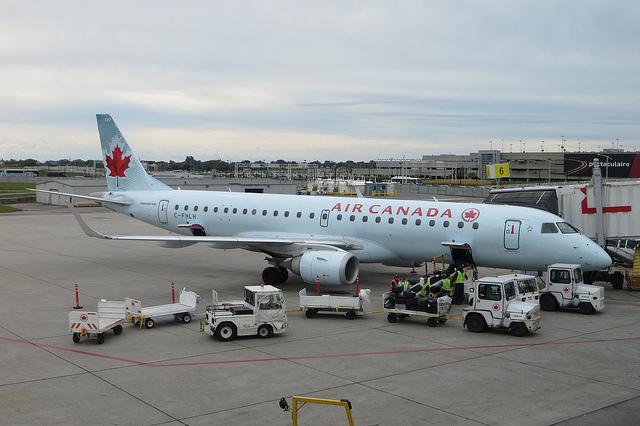Is the plane's door open?
Give a very brief answer. No. Is the plane taking off?
Give a very brief answer. No. Is the plane being loaded with cargo?
Be succinct. Yes. Why is the truck next to the plane?
Short answer required. Loading luggage. How many people are boarding the plane?
Be succinct. 0. Is this plane taking off?
Keep it brief. No. What is the name of the airline?
Be succinct. Air canada. What says air Canada?
Be succinct. Airplane. Is this a Mexican plane?
Short answer required. No. How many vehicles are near the plane?
Write a very short answer. 4. 